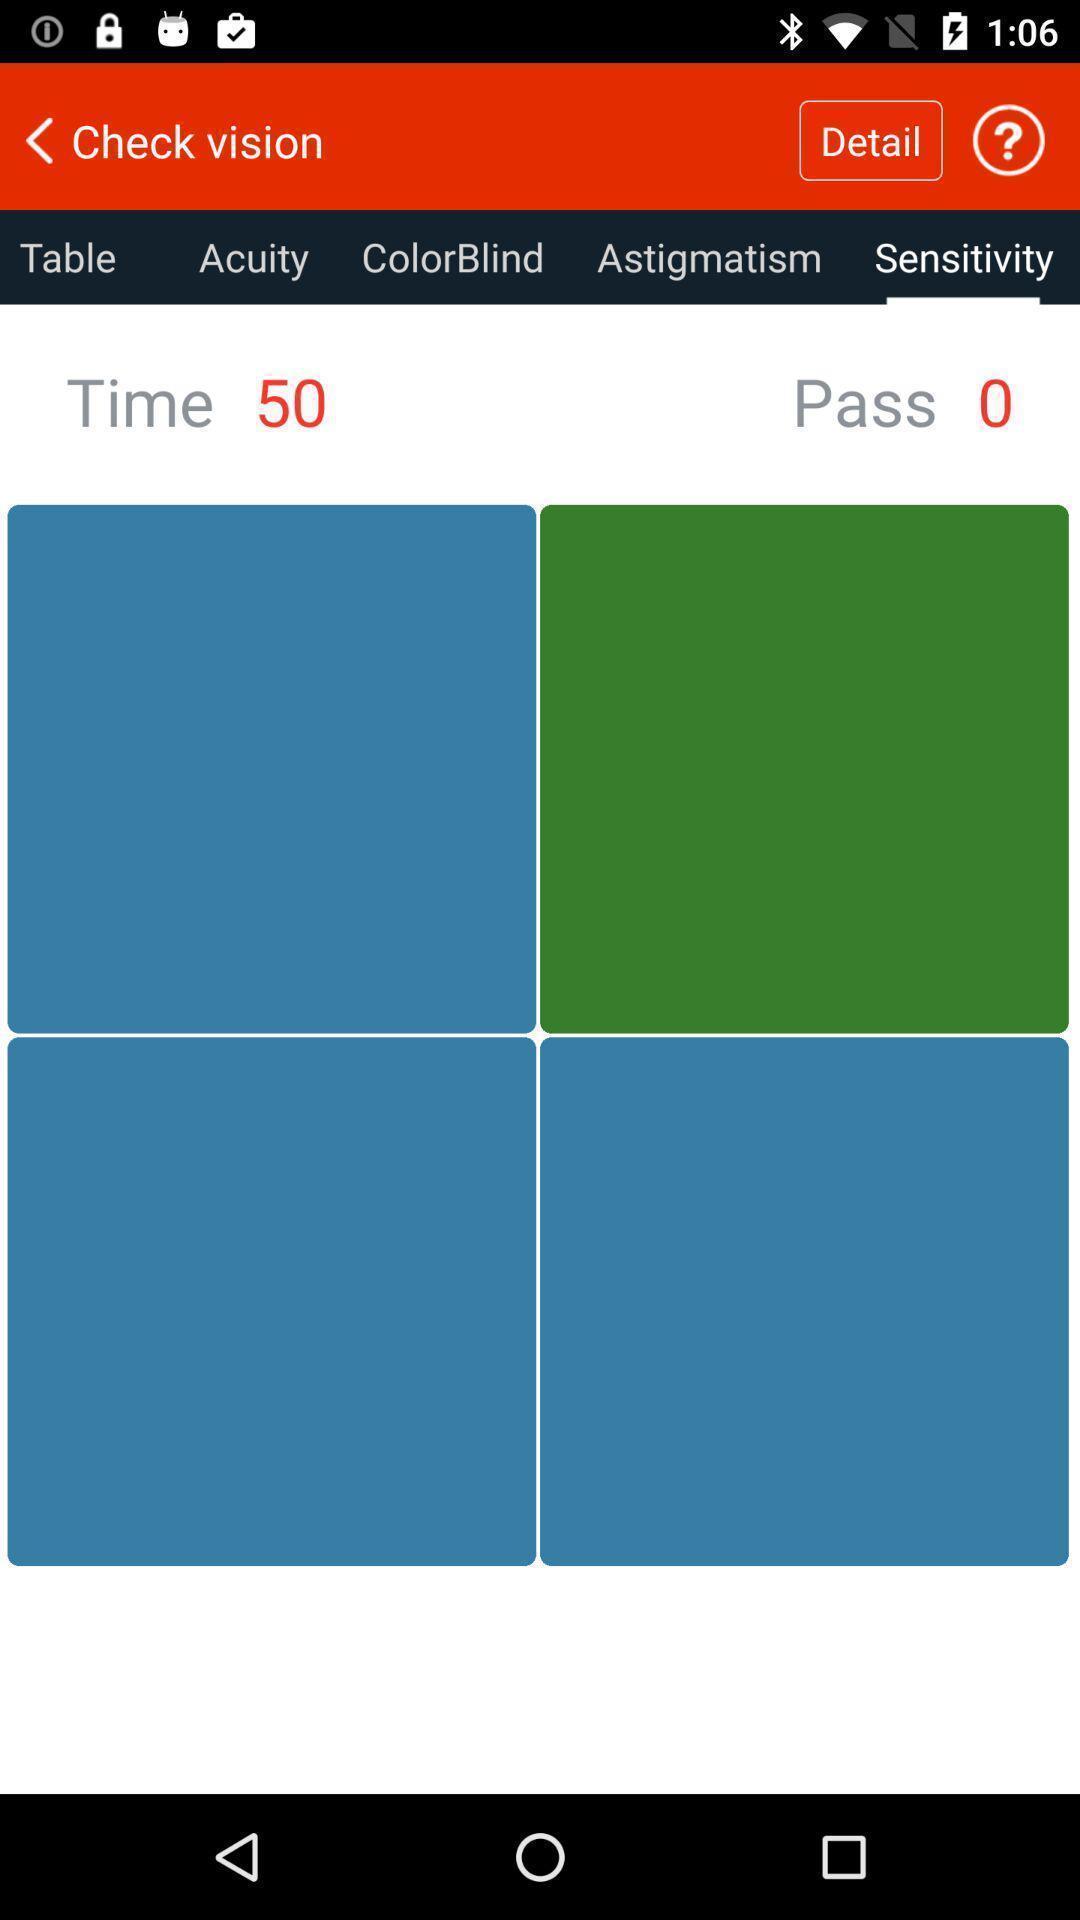Tell me what you see in this picture. Sensitivity details of time and pass options on viewer app. 